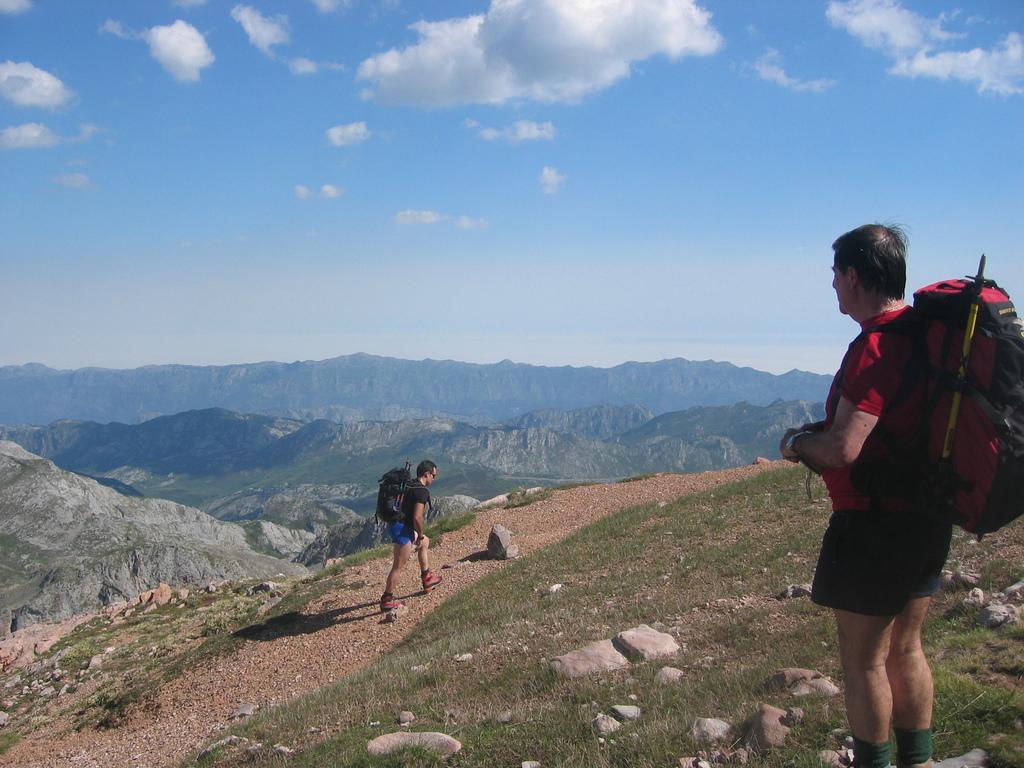How would you summarize this image in a sentence or two? In this picture we can see two persons here. Both are wearing their backpacks. And in the background there is a mountain. This is the sky with clouds. And these are the stones. And this is grass. 